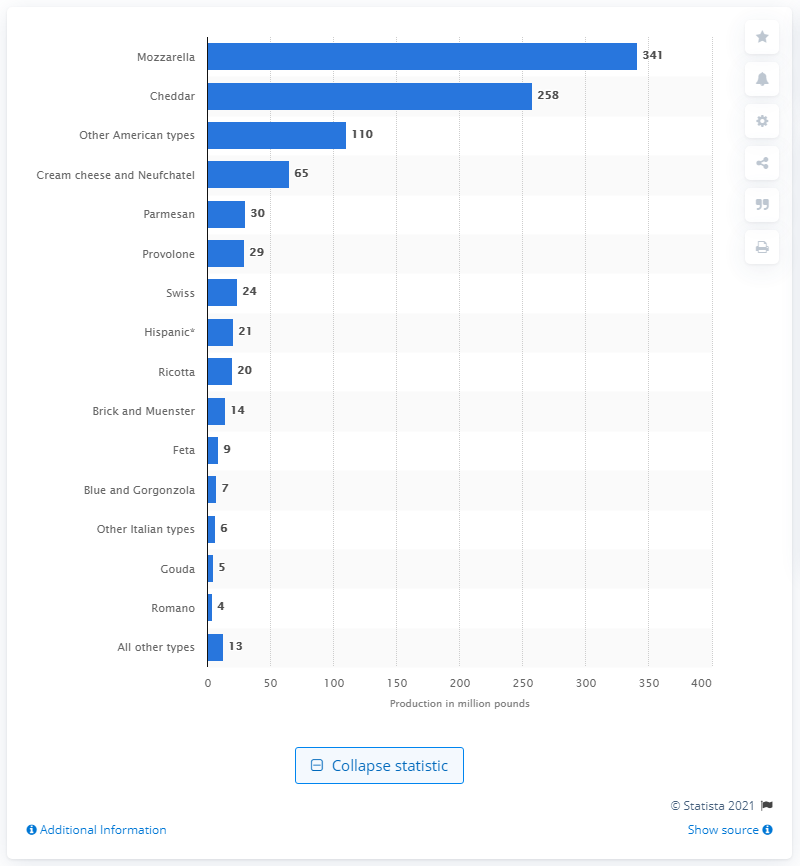Mention a couple of crucial points in this snapshot. In February 2016, the amount of provolone cheese produced in the United States was 29 million pounds. 